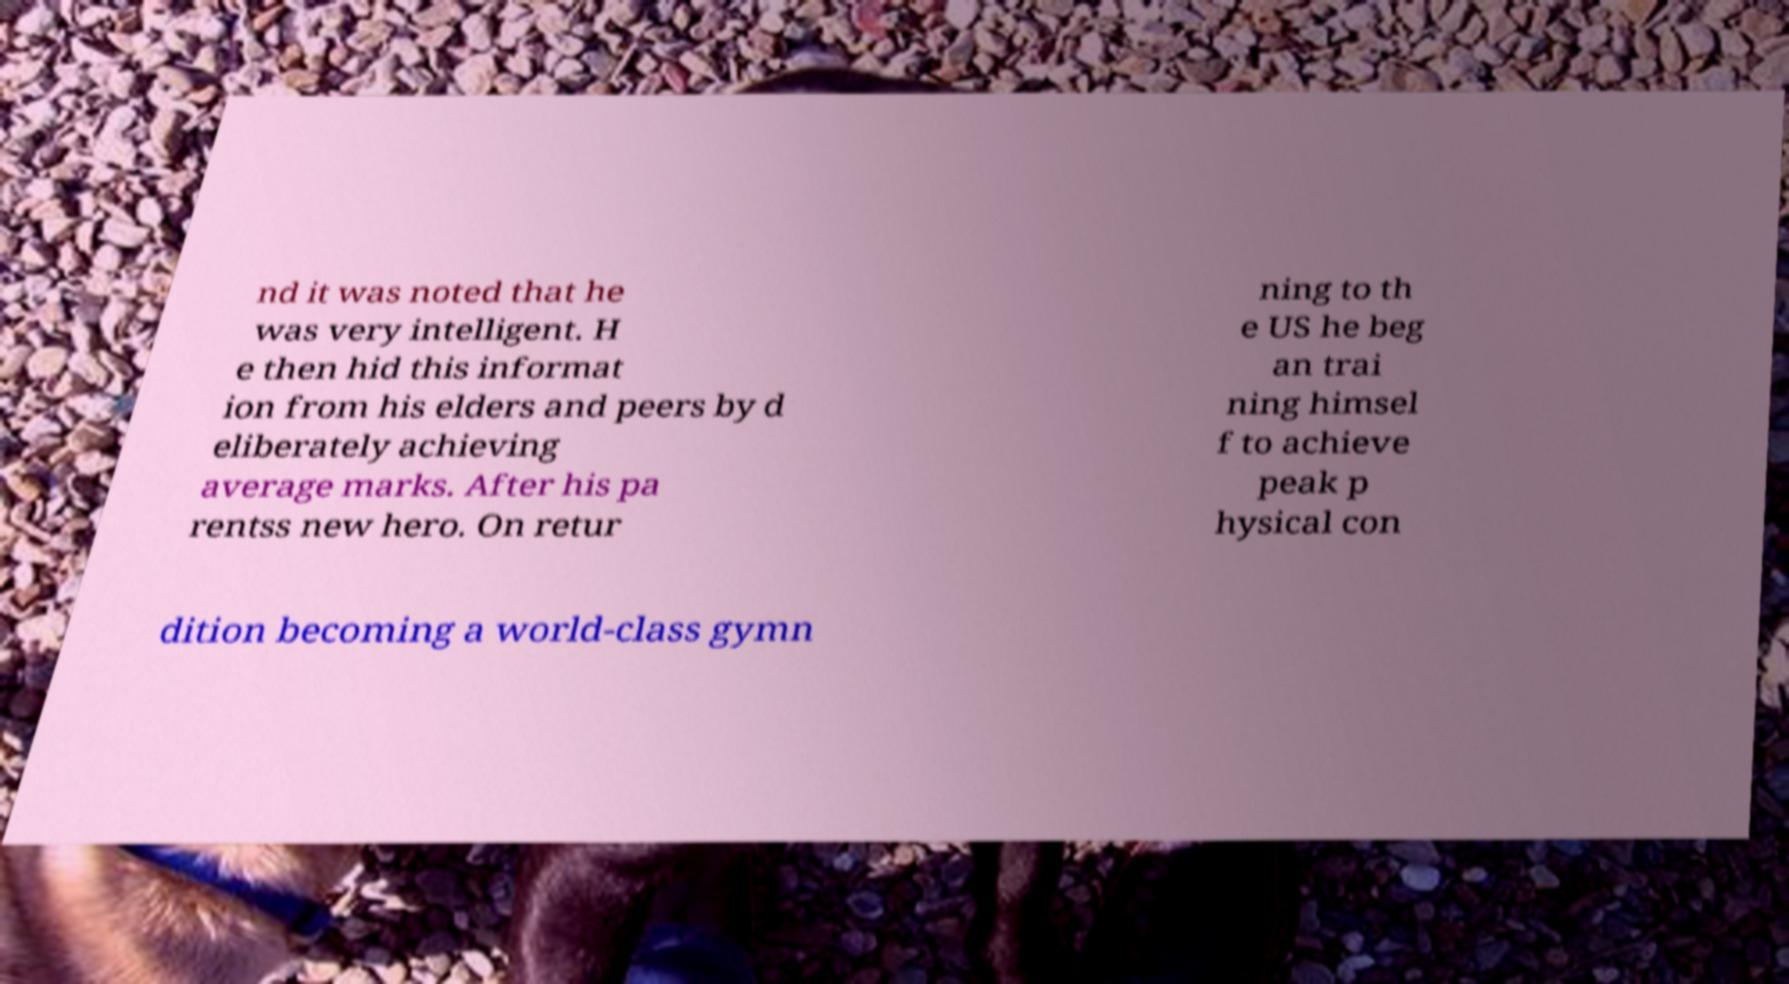Can you read and provide the text displayed in the image?This photo seems to have some interesting text. Can you extract and type it out for me? nd it was noted that he was very intelligent. H e then hid this informat ion from his elders and peers by d eliberately achieving average marks. After his pa rentss new hero. On retur ning to th e US he beg an trai ning himsel f to achieve peak p hysical con dition becoming a world-class gymn 